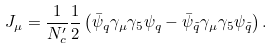<formula> <loc_0><loc_0><loc_500><loc_500>J _ { \mu } = \frac { 1 } { N _ { c } ^ { \prime } } \frac { 1 } { 2 } \left ( \bar { \psi } _ { q } \gamma _ { \mu } \gamma _ { 5 } \psi _ { q } - \bar { \psi } _ { \tilde { q } } \gamma _ { \mu } \gamma _ { 5 } \psi _ { \tilde { q } } \right ) .</formula> 